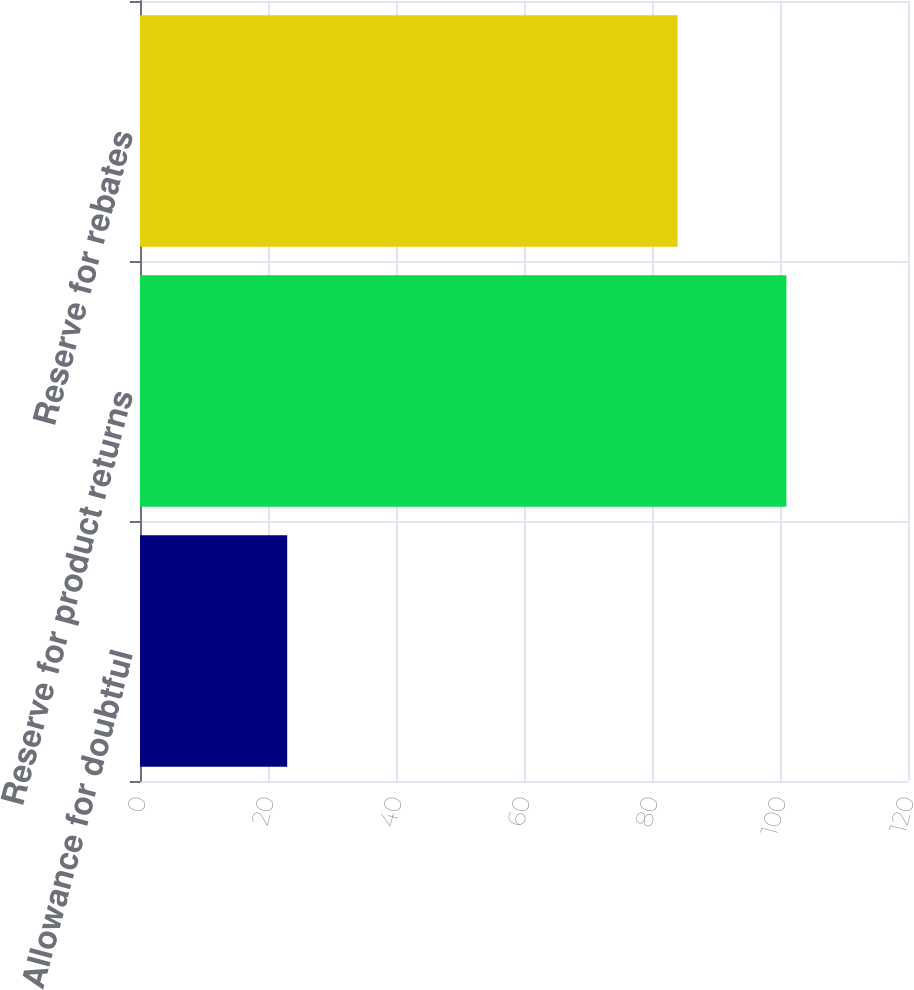Convert chart. <chart><loc_0><loc_0><loc_500><loc_500><bar_chart><fcel>Allowance for doubtful<fcel>Reserve for product returns<fcel>Reserve for rebates<nl><fcel>23<fcel>101<fcel>84<nl></chart> 